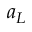Convert formula to latex. <formula><loc_0><loc_0><loc_500><loc_500>a _ { L }</formula> 